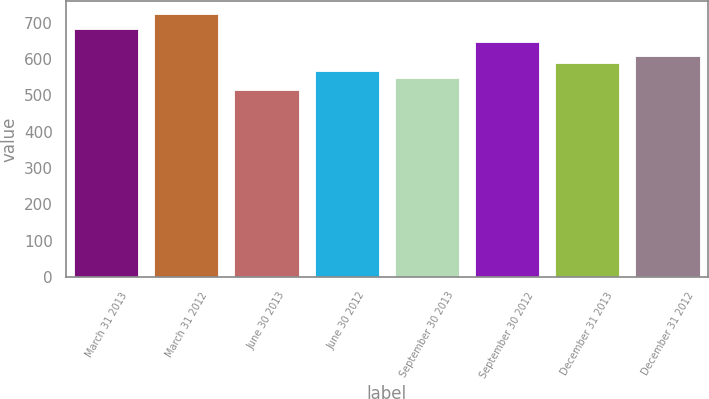Convert chart to OTSL. <chart><loc_0><loc_0><loc_500><loc_500><bar_chart><fcel>March 31 2013<fcel>March 31 2012<fcel>June 30 2013<fcel>June 30 2012<fcel>September 30 2013<fcel>September 30 2012<fcel>December 31 2013<fcel>December 31 2012<nl><fcel>684<fcel>724<fcel>516<fcel>567.8<fcel>547<fcel>648<fcel>588.6<fcel>609.4<nl></chart> 